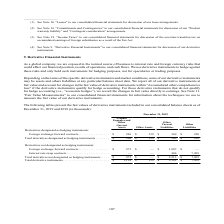According to First Solar's financial document, How are changes in fair value of hedging instruments accounted for? within “Accumulated other comprehensive loss”. The document states: "hanges in the fair value of derivative instruments within “Accumulated other comprehensive loss” if the derivative instruments qualify for hedge accou..." Also, What risks are hedged using the derivative instruments? interest rate and foreign currency risks. The document states: "e are exposed in the normal course of business to interest rate and foreign currency risks that could affect our financial position, results of operat..." Also, What is the total derivate instruments for other liabilities? According to the financial document, $7,439 (in thousands). The relevant text states: "derivative instruments . $ 1,199 $ 139 $ 2,582 $ 7,439..." Also, can you calculate: What is the difference in the total derivative instruments between other assets and other current liabilities? Based on the calculation: 139-2,582, the result is -2443 (in thousands). This is based on the information: "09 Total derivative instruments . $ 1,199 $ 139 $ 2,582 $ 7,439 nts: Foreign exchange forward contracts . $ 226 $ 139 $ 369 $ 230 Total derivatives designated as hedging instruments . $ 226 $ 139 $ 36..." The key data points involved are: 139, 2,582. Also, can you calculate: Under prepaid expenses and other current assets, what is the ratio of the total derivates designated as hedging instruments to those not designated as hedging instruments? Based on the calculation: 226/973, the result is 0.23. This is based on the information: "struments: Foreign exchange forward contracts . $ 973 $ — $ 1,807 $ — Interest rate swap contracts . — — 406 7,209 Total derivatives not designated as he struments: Foreign exchange forward contracts ..." The key data points involved are: 226, 973. Also, can you calculate: What is the difference in the foreign exchange forward contracts for hedging instruments between other assets and other liabilities? Based on the calculation: 139-230, the result is -91 (in thousands). This is based on the information: "exchange forward contracts . $ 226 $ 139 $ 369 $ 230 Total derivatives designated as hedging instruments . $ 226 $ 139 $ 369 $ 230 nts: Foreign exchange forward contracts . $ 226 $ 139 $ 369 $ 230 Tot..." The key data points involved are: 139, 230. 